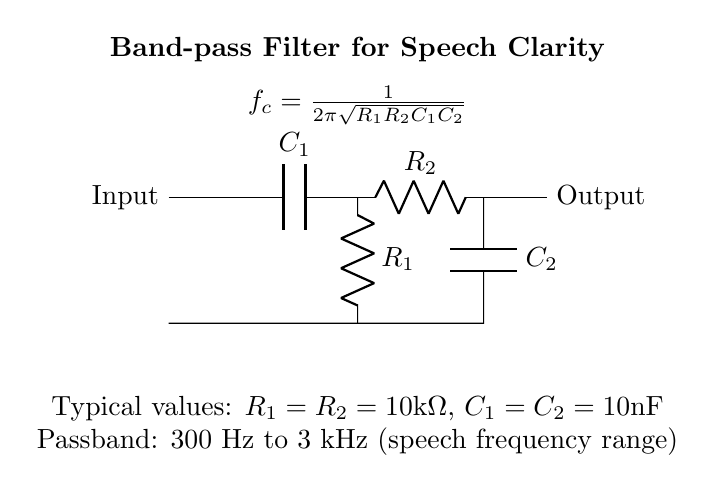What are the main components of this circuit? The circuit contains two resistors, R1 and R2, and two capacitors, C1 and C2. The resistors and capacitors form a band-pass filter designed to enhance speech clarity.
Answer: Resistors and capacitors What is the function of C1 and C2 in the circuit? C1 and C2 are capacitors that work with the resistors R1 and R2 to set the cut-off frequencies for the band-pass filter, allowing only certain frequencies to pass through while blocking others.
Answer: Set cut-off frequencies What is the value of R1 and R2? Both R1 and R2 are specified to have a value of 10 kilo-ohms in the provided circuit information. This value determines how the circuit will respond to the input signal.
Answer: 10 kilo-ohms What is the passband frequency range of this filter? The filter is designed to allow frequencies between 300 Hz and 3 kHz to pass through, which is the typical range for human speech. This specific range enhances the clarity of spoken audio.
Answer: 300 Hz to 3 kHz How is the center frequency calculated in this circuit? The center frequency, denoted as fc, is calculated using the formula fc = 1 / (2π√(R1R2C1C2)). This relation shows that the center frequency depends on the values of both the resistors and capacitors in the circuit.
Answer: fc = 1 / (2π√(R1R2C1C2)) What is the overall purpose of this circuit? The overall purpose of the band-pass filter circuit is to enhance speech clarity in audiobook players by allowing only specific frequency ranges related to speech to be amplified while attenuating other frequencies that may obscure the sound quality.
Answer: Enhance speech clarity 